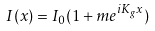Convert formula to latex. <formula><loc_0><loc_0><loc_500><loc_500>I ( x ) = I _ { 0 } ( 1 + m e ^ { i K _ { g } x } )</formula> 